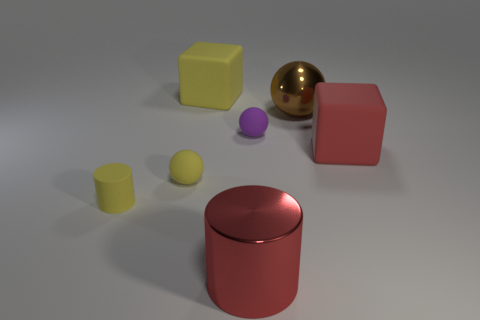The big cube behind the cube that is in front of the rubber thing behind the tiny purple thing is what color?
Offer a terse response. Yellow. Does the yellow ball have the same material as the yellow cylinder?
Your response must be concise. Yes. What number of gray things are metallic balls or big matte blocks?
Your answer should be compact. 0. What number of rubber objects are in front of the big brown shiny thing?
Provide a succinct answer. 4. Is the number of big objects greater than the number of tiny red rubber things?
Provide a short and direct response. Yes. There is a big rubber thing on the right side of the rubber ball that is to the right of the yellow block; what is its shape?
Provide a short and direct response. Cube. Are there more small matte objects to the left of the small purple matte ball than brown objects?
Provide a succinct answer. Yes. There is a large block behind the purple ball; what number of rubber objects are to the right of it?
Offer a terse response. 2. Do the block that is to the left of the red matte cube and the sphere that is in front of the red matte cube have the same material?
Your answer should be very brief. Yes. There is a large cube that is the same color as the tiny matte cylinder; what is it made of?
Provide a short and direct response. Rubber. 